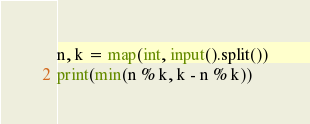<code> <loc_0><loc_0><loc_500><loc_500><_Python_>n, k = map(int, input().split())
print(min(n % k, k - n % k))</code> 